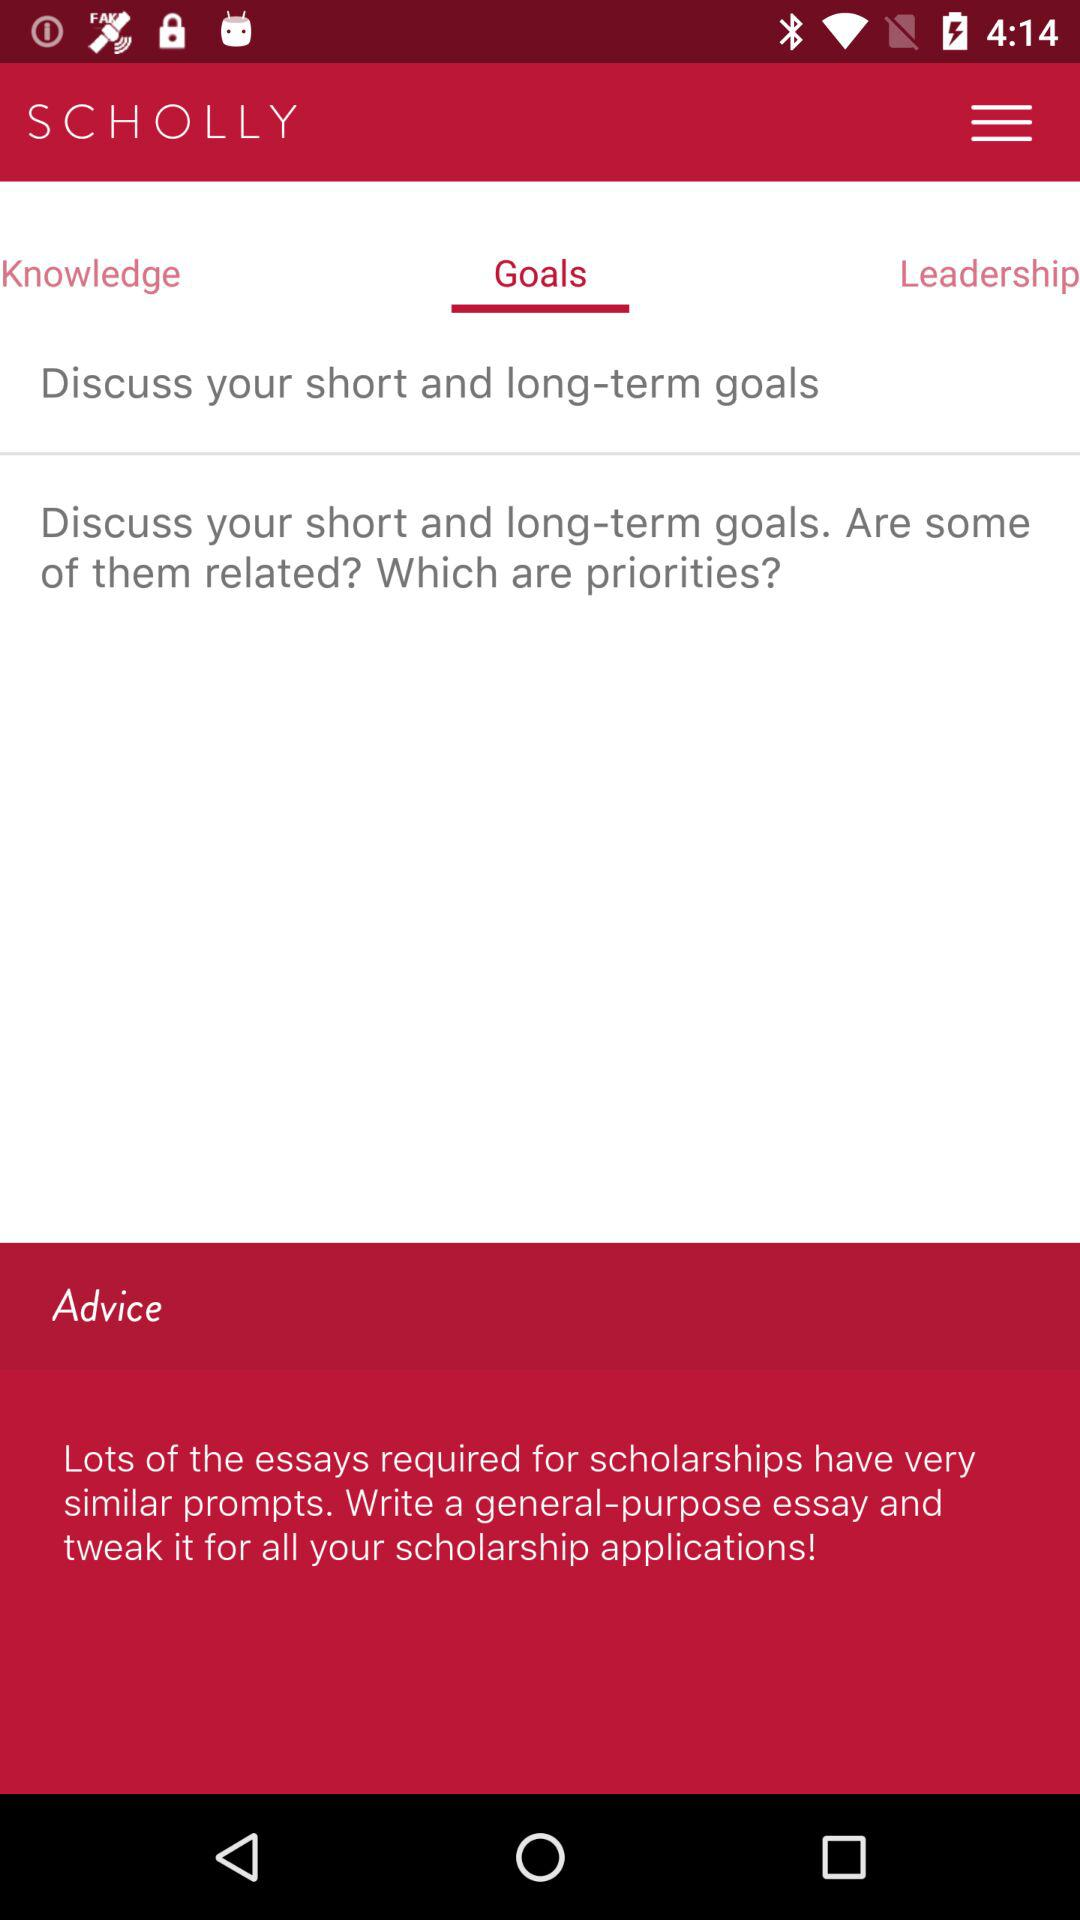Which tab am I on? You are on the "Goals" tab. 